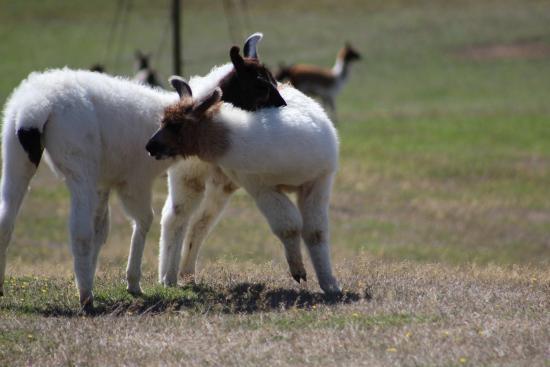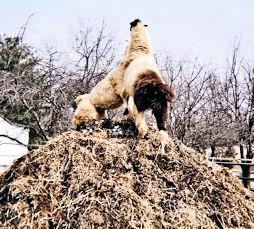The first image is the image on the left, the second image is the image on the right. Analyze the images presented: Is the assertion "In at least one image there are at least three mountain peaks behind a single llama." valid? Answer yes or no. No. The first image is the image on the left, the second image is the image on the right. Given the left and right images, does the statement "The left image includes a leftward-facing brown-and-white llama standing at the edge of a cliff, with mountains in the background." hold true? Answer yes or no. No. 